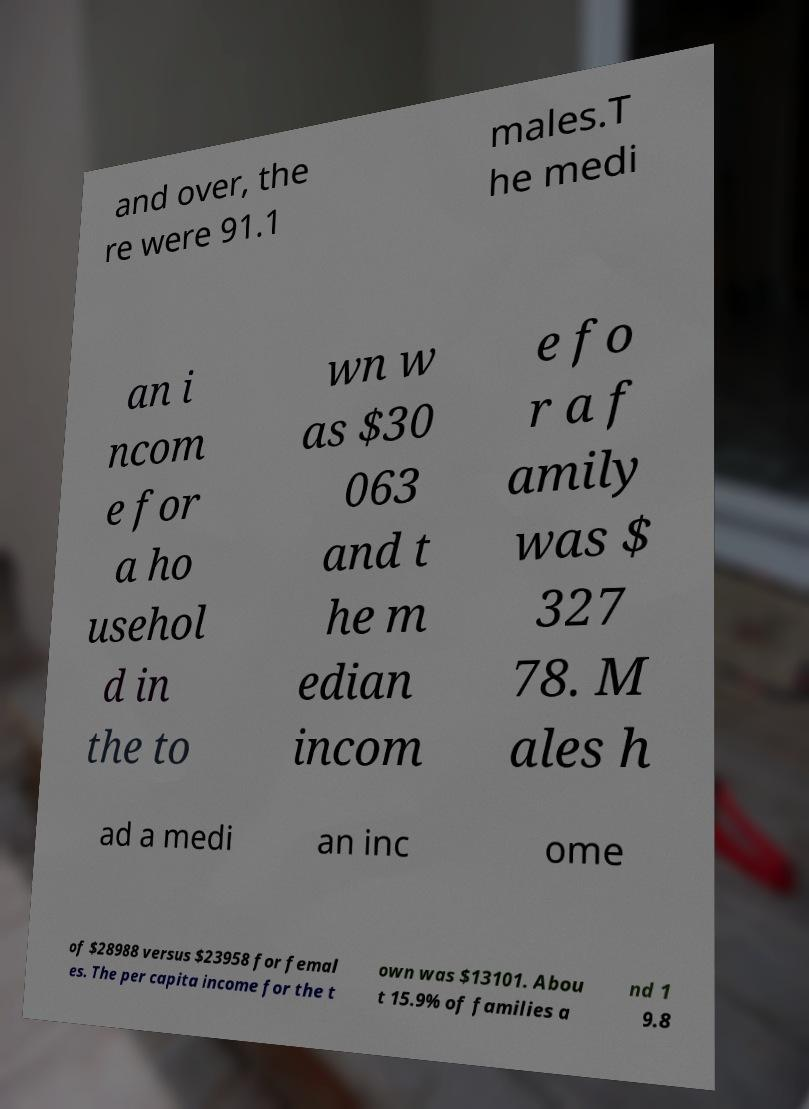There's text embedded in this image that I need extracted. Can you transcribe it verbatim? and over, the re were 91.1 males.T he medi an i ncom e for a ho usehol d in the to wn w as $30 063 and t he m edian incom e fo r a f amily was $ 327 78. M ales h ad a medi an inc ome of $28988 versus $23958 for femal es. The per capita income for the t own was $13101. Abou t 15.9% of families a nd 1 9.8 